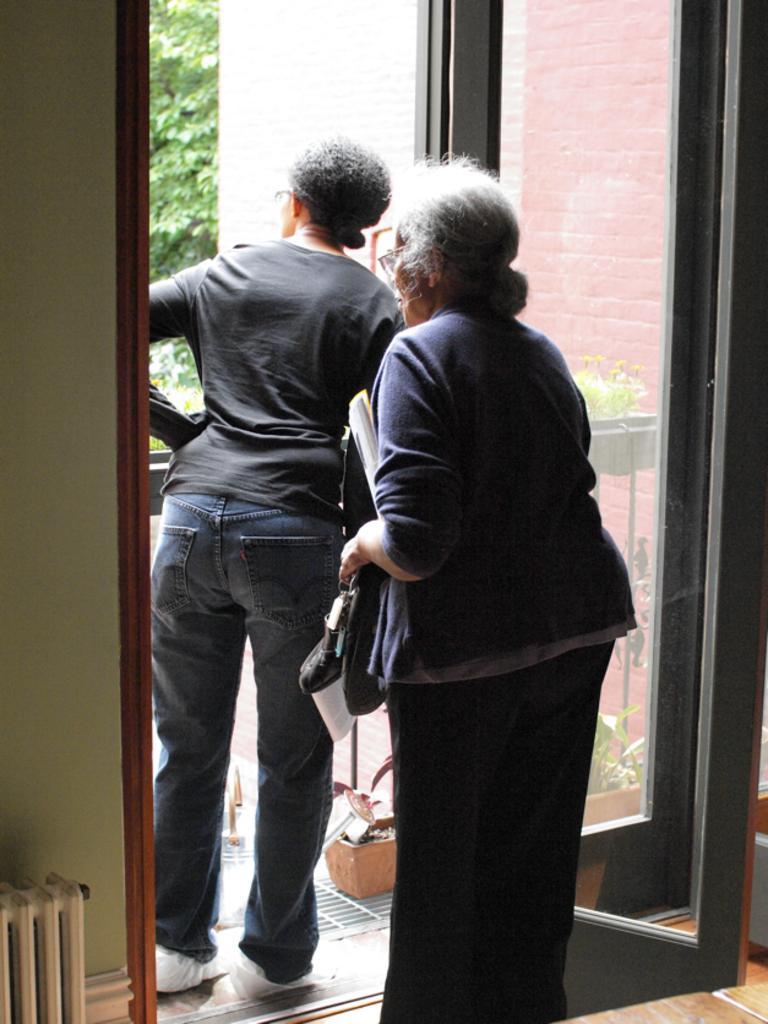Please provide a concise description of this image. In this picture I can see couple of women standing and I can see a building and few plants in the pots and looks like a tree in the background. 